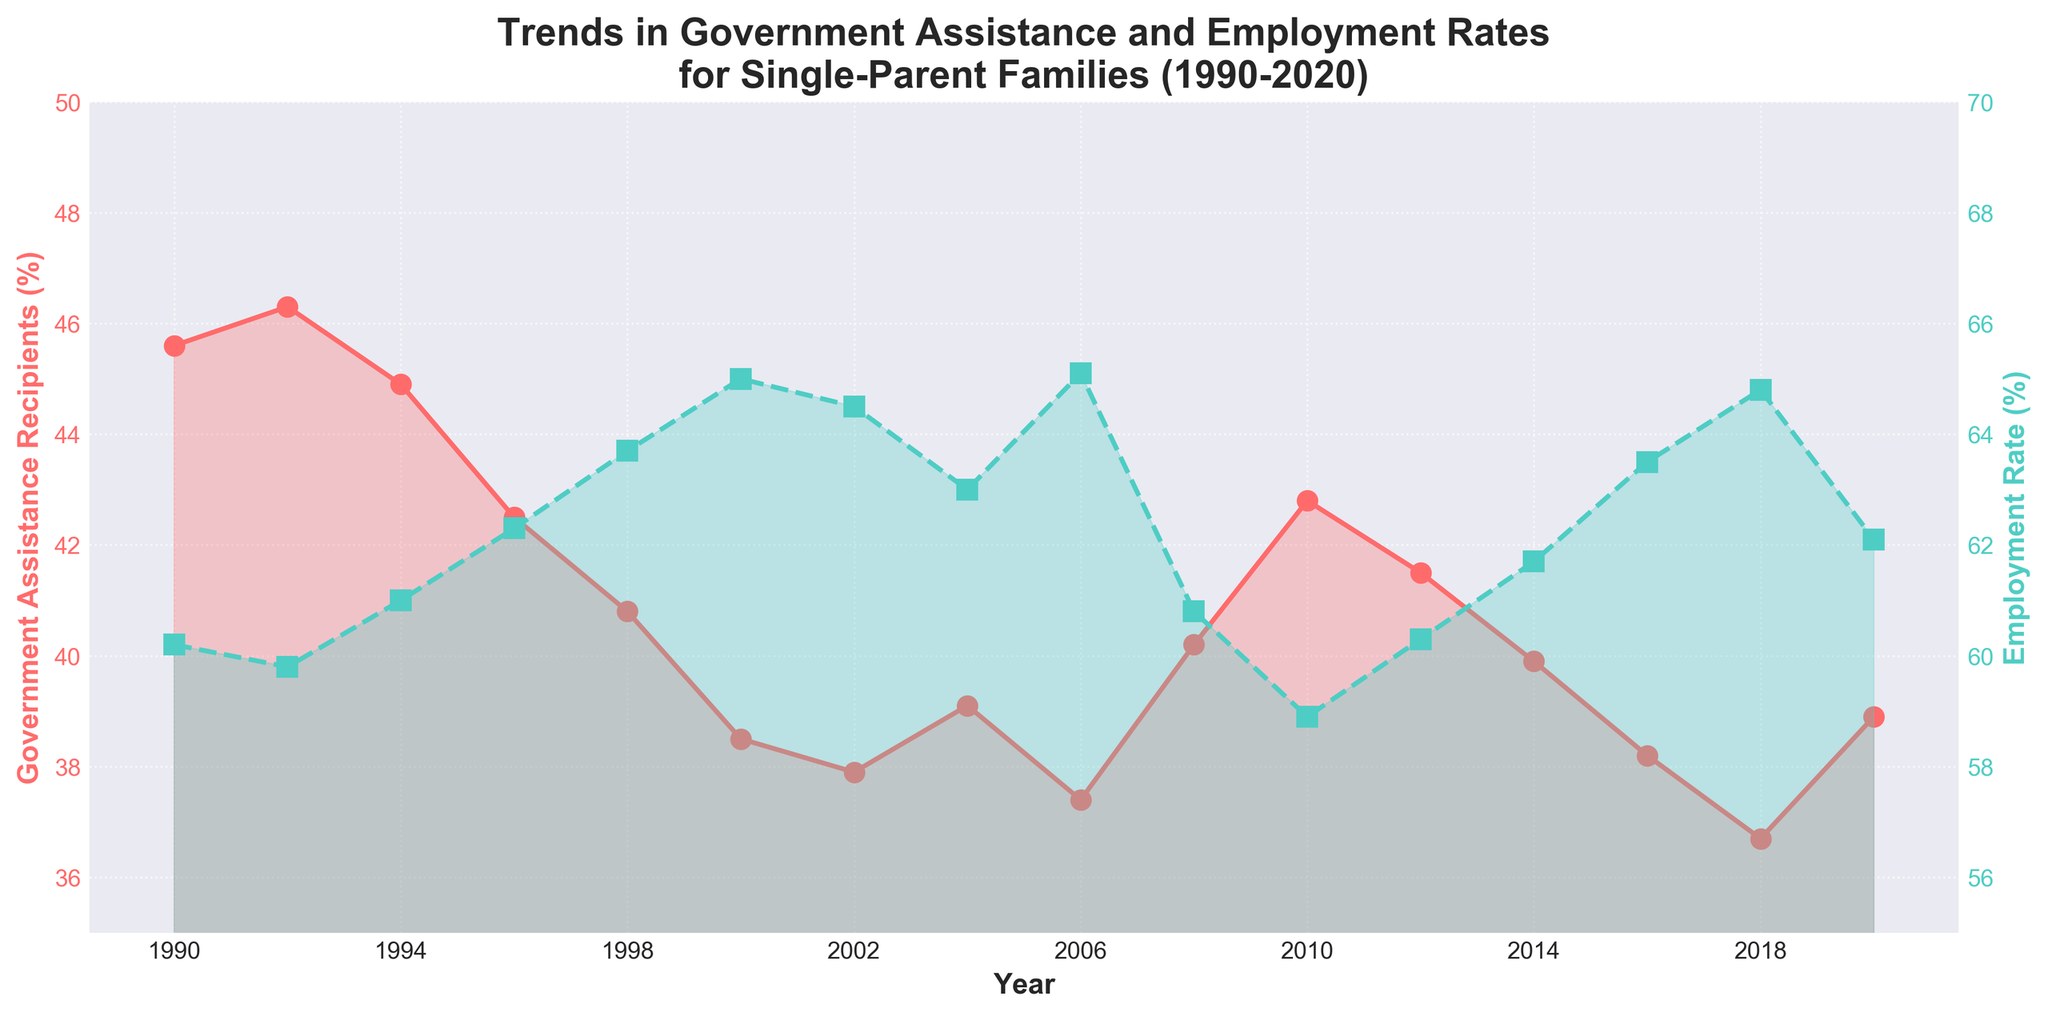What is the general trend in government assistance received by single-parent families from 1990 to 2020? The general trend shows a gradual decrease, with some fluctuations near the year 2008. Initial percentage is 45.6% in 1990 and it decreases to 38.9% in 2020.
Answer: A decrease What are the colors used to represent Government Assistance Recipients and Employment Rate? Government Assistance Recipients are represented by a red line and Employment Rate by a green line.
Answer: Red for Government Assistance and Green for Employment Rate How does the employment rate trend compare to the trend in government assistance from 1990 to 2020? The trend in employment rates generally increases over time, which is in contrast to the decreasing trend in government assistance. Employment Rate starts at 60.2% in 1990 and reaches 62.1% in 2020.
Answer: Opposite trends What is the approximate percentage of government assistance recipients in 2008? In 2008, the percentage is approximately 40.2%.
Answer: 40.2% Which year had the highest employment rate for single-parent families? The highest employment rate is in the year 2006, with a percentage of 65.1%.
Answer: 2006 By how much did the employment rate change from 1990 to 2020? The employment rate started at 60.2% in 1990 and went up to 62.1% in 2020. The difference is 62.1% - 60.2% = 1.9%.
Answer: 1.9% Which year shows the lowest percentage of government assistance recipients? The lowest percentage of government assistance recipients is in 2018, at 36.7%.
Answer: 2018 In which year did government assistance see a significant decrease followed by a subsequent increase? A significant decrease followed by an increase is observed around 2008. The percentage drops from 39.1% in 2004 to 37.4% in 2006, then increases to 40.2% in 2008.
Answer: 2008 How do the trends in government assistance and employment rates in 2008 compare? In 2008, government assistance shows an increase while employment rates show a decrease. Government assistance rises to 40.2% and employment rates drop to 60.8%.
Answer: Increase in assistance, decrease in employment What was the change in government assistance percentage between 2000 and 2002? The percentage for government assistance was 38.5% in 2000 and 37.9% in 2002. The change is 37.9% - 38.5% = -0.6%.
Answer: -0.6% 